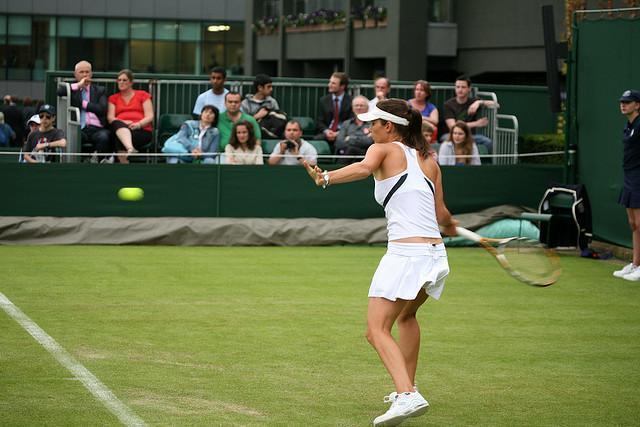How many people are in the photo?
Give a very brief answer. 4. 